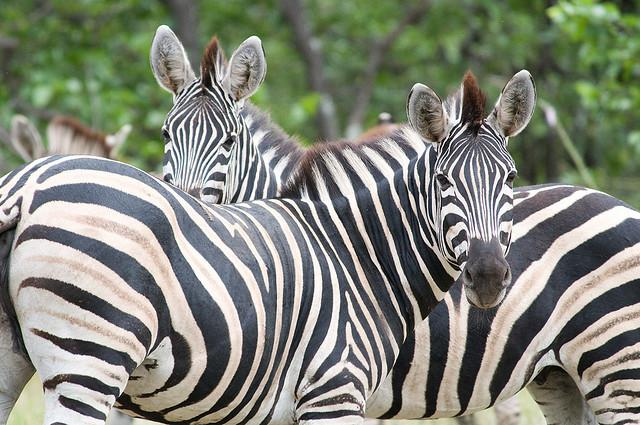How many zebras are standing in the forest with their noses pointed at the cameras? Please explain your reasoning. two. There are 2. 